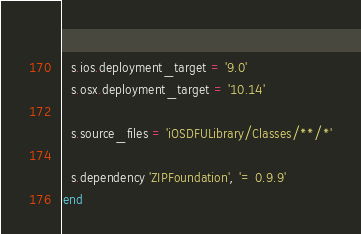<code> <loc_0><loc_0><loc_500><loc_500><_Ruby_>  
  s.ios.deployment_target = '9.0'
  s.osx.deployment_target = '10.14'

  s.source_files = 'iOSDFULibrary/Classes/**/*'

  s.dependency 'ZIPFoundation', '= 0.9.9'
end
</code> 